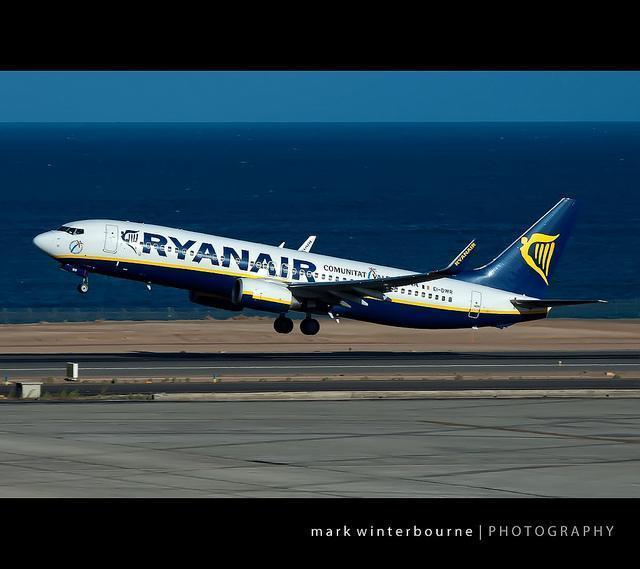How many people are looking toward the camera?
Give a very brief answer. 0. 